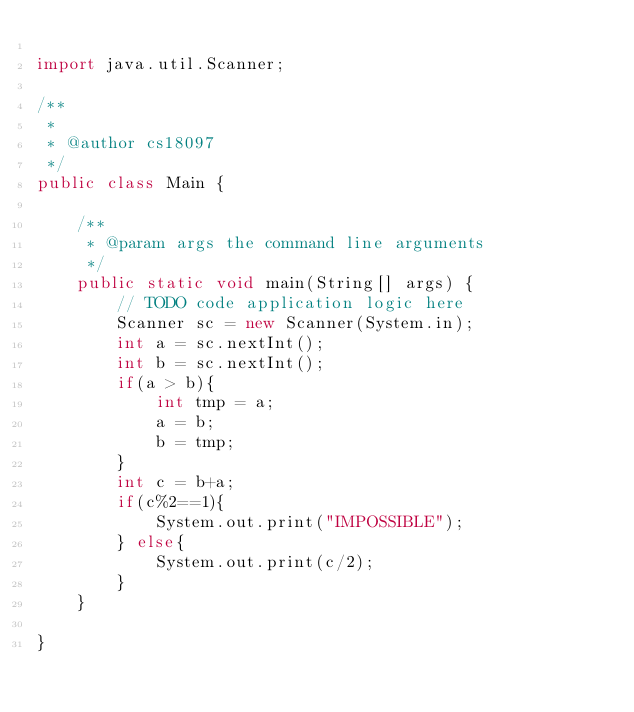<code> <loc_0><loc_0><loc_500><loc_500><_Java_>
import java.util.Scanner;

/**
 *
 * @author cs18097
 */
public class Main {

    /**
     * @param args the command line arguments
     */
    public static void main(String[] args) {
        // TODO code application logic here
        Scanner sc = new Scanner(System.in);
        int a = sc.nextInt();
        int b = sc.nextInt();
        if(a > b){
            int tmp = a;
            a = b;
            b = tmp;
        }
        int c = b+a;
        if(c%2==1){
            System.out.print("IMPOSSIBLE");
        } else{
            System.out.print(c/2);
        }
    }
    
}
</code> 